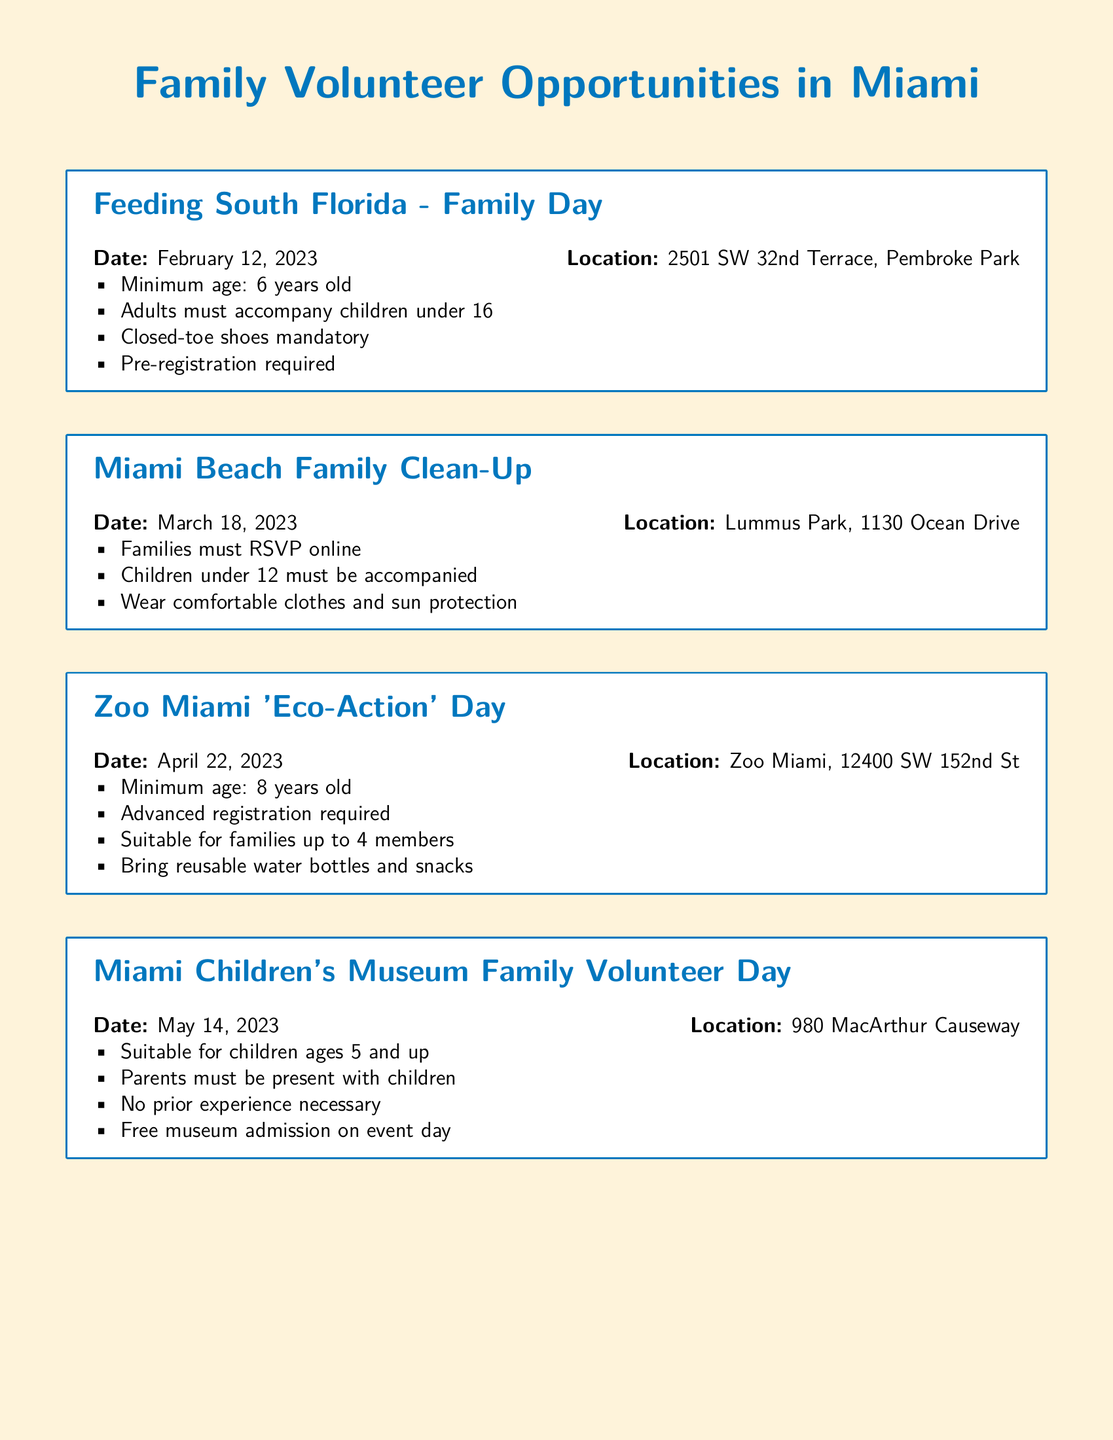What is the date for the Miami Beach Family Clean-Up? The date for the Miami Beach Family Clean-Up is mentioned in the event detail, which is March 18, 2023.
Answer: March 18, 2023 What is the minimum age for Feeding South Florida Family Day? The minimum age for this event is stated as 6 years old.
Answer: 6 years old Where is the Habitat for Humanity Family Build Day located? The location for the Habitat for Humanity Family Build Day is provided as 3800 NW 22nd Ave.
Answer: 3800 NW 22nd Ave What is required for children under 12 at the Miami Beach Family Clean-Up? The document states that children under 12 must be accompanied by an adult.
Answer: Accompanied by an adult Is pre-registration required for Zoo Miami 'Eco-Action' Day? The events details specify that advanced registration is indeed required.
Answer: Yes What age group is suitable for Miami Children's Museum Family Volunteer Day? The event is suitable for children ages 5 and up, as stated in the details.
Answer: Ages 5 and up What type of clothing is recommended for Habitat for Humanity Family Build Day? The document recommends wearing sturdy clothing and closed-toe shoes for this event.
Answer: Sturdy clothing and closed-toe shoes How many family members can participate in Zoo Miami 'Eco-Action' Day? The document mentions that the event is suitable for families up to 4 members.
Answer: Up to 4 members 